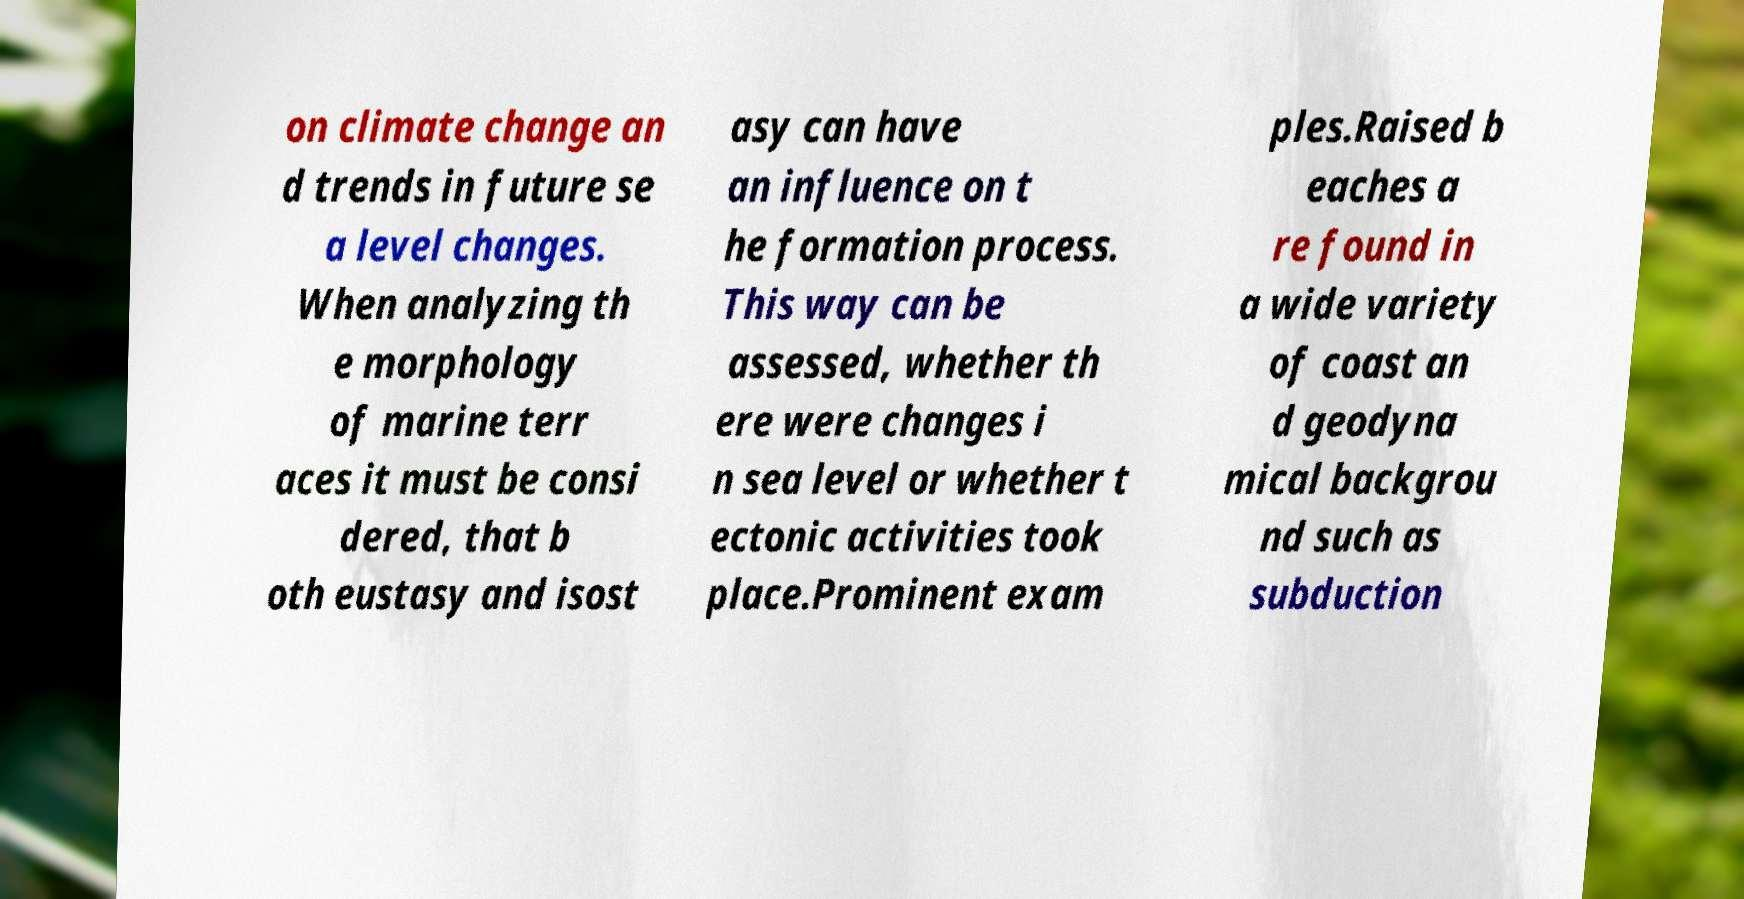Can you read and provide the text displayed in the image?This photo seems to have some interesting text. Can you extract and type it out for me? on climate change an d trends in future se a level changes. When analyzing th e morphology of marine terr aces it must be consi dered, that b oth eustasy and isost asy can have an influence on t he formation process. This way can be assessed, whether th ere were changes i n sea level or whether t ectonic activities took place.Prominent exam ples.Raised b eaches a re found in a wide variety of coast an d geodyna mical backgrou nd such as subduction 